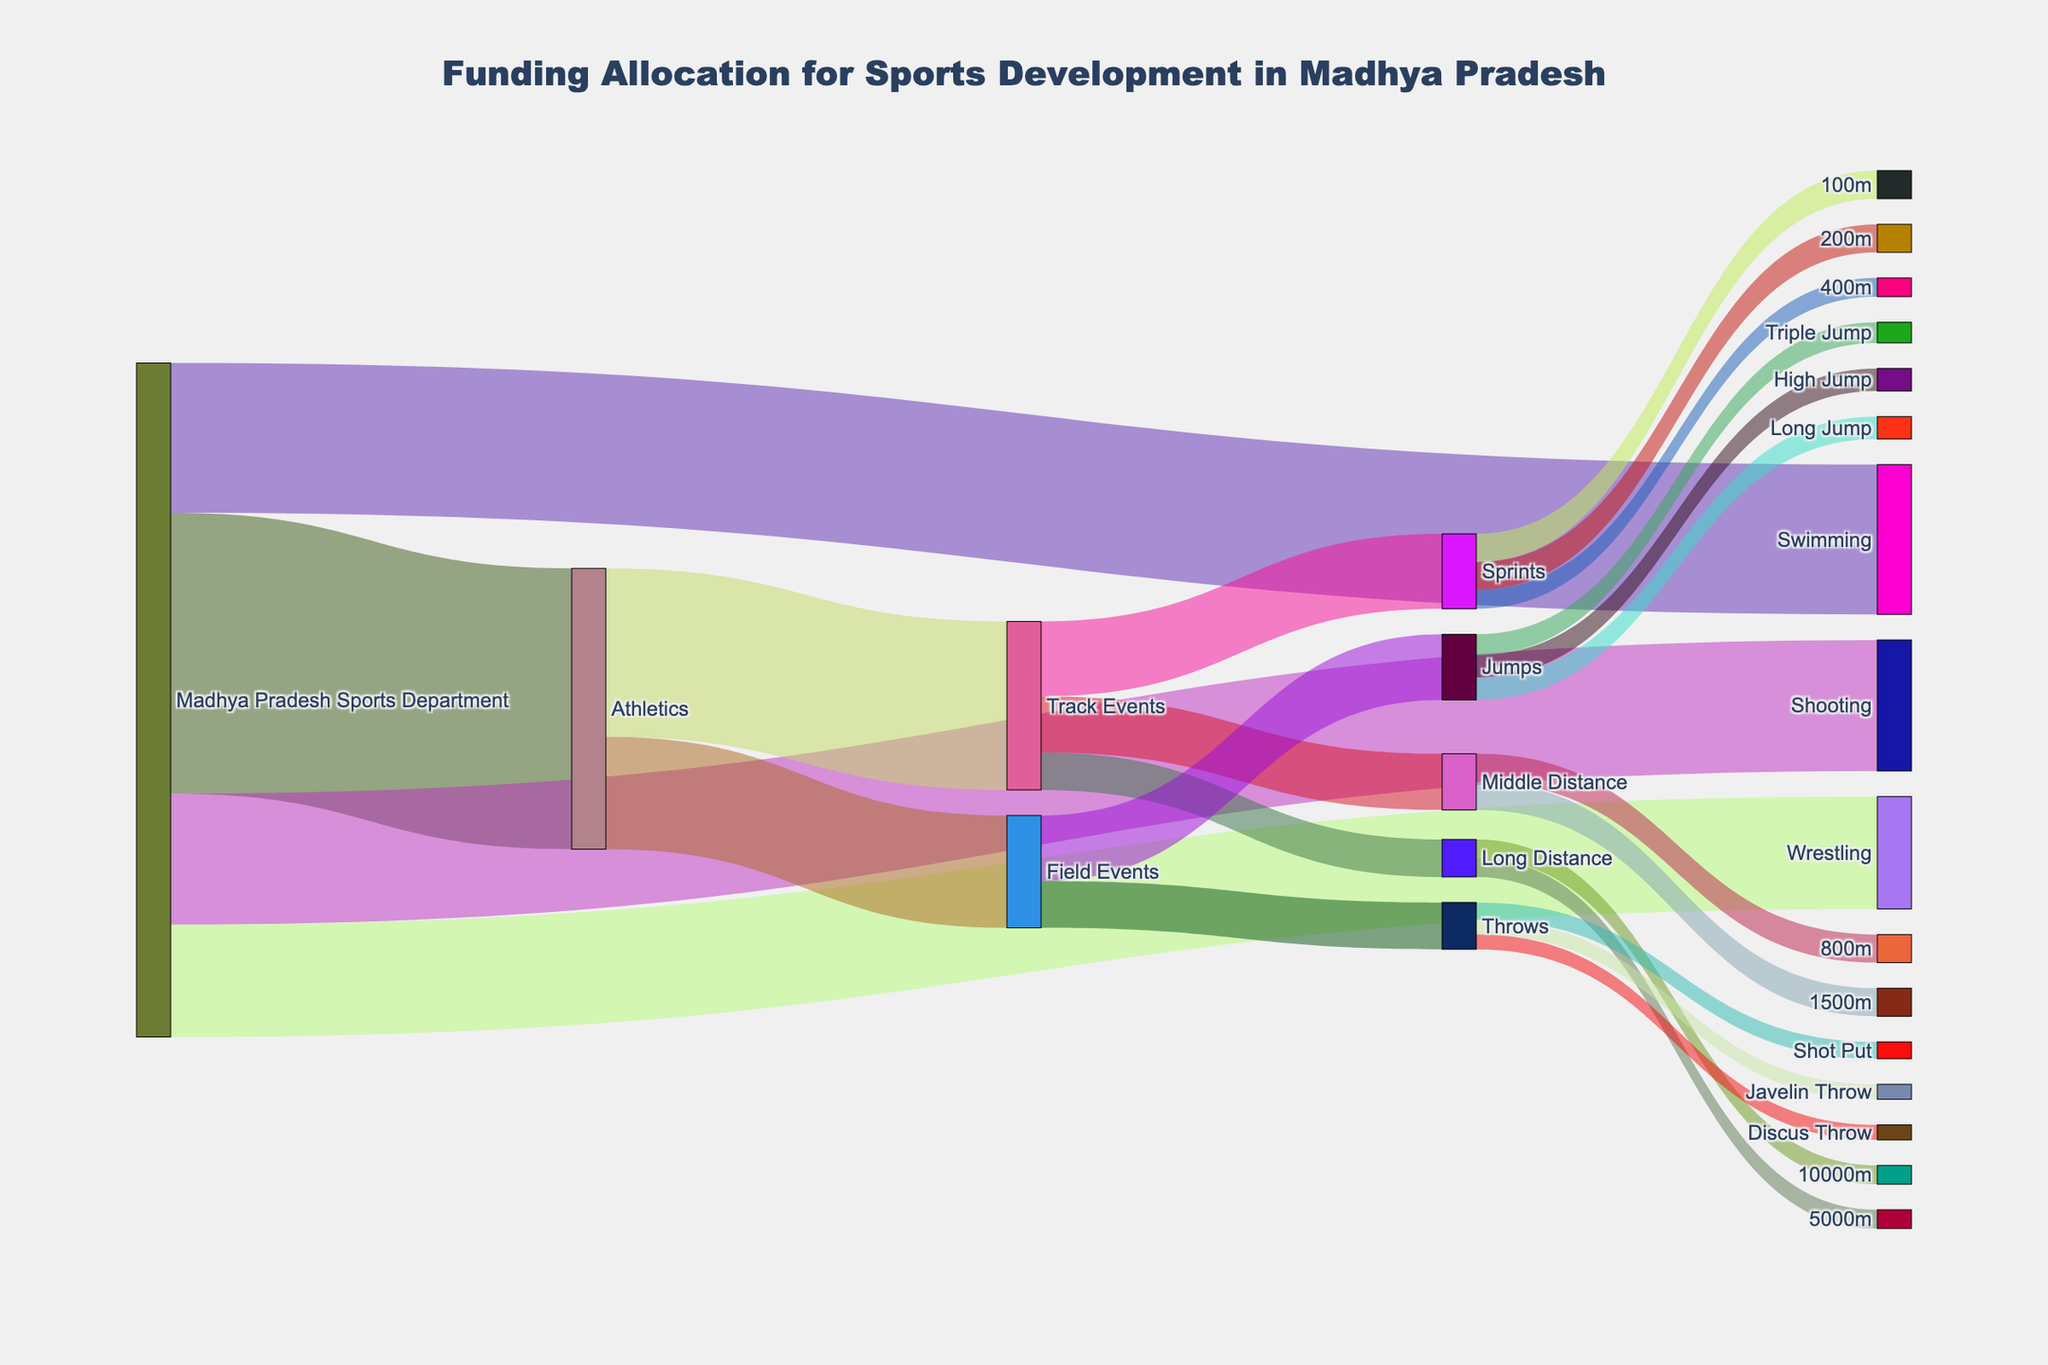How much funding does the Madhya Pradesh Sports Department allocate to Athletics compared to Wrestling? The Sankey Diagram shows funding allocations where Madhya Pradesh Sports Department allocates ₹15,000,000 to Athletics and ₹6,000,000 to Wrestling.
Answer: ₹15,000,000 vs ₹6,000,000 Which Track Event receives the most funding? By examining the Sankey Diagram, we see Track Events splitting into Sprints, Middle Distance, and Long Distance. Sprints gets ₹4,000,000, Middle Distance ₹3,000,000, and Long Distance ₹2,000,000. Sprints receive the most funding.
Answer: Sprints How much total funding is allocated to Field Events? The fields for Field Events are Jumps and Throws, receiving ₹3,500,000 and ₹2,500,000 respectively. Summing these gives ₹3,500,000 + ₹2,500,000 = ₹6,000,000.
Answer: ₹6,000,000 What funding is allocated to the Long Jump event? The Sankey Diagram shows that Jumps within Field Events is further broken down, and Long Jump receives ₹1,200,000.
Answer: ₹1,200,000 Which sports category receives the least overall funding from the Madhya Pradesh Sports Department? Looking at the initial allocations from the Madhya Pradesh Sports Department, funds are directed to Athletics, Swimming, Shooting, and Wrestling. Wrestling receives the least amount at ₹6,000,000.
Answer: Wrestling What's the total funding allocated to Middle Distance track events? The Middle Distance category under Track Events receives funds for 800m and 1500m events. Each event gets ₹1,500,000, summing up to ₹1,500,000 + ₹1,500,000 = ₹3,000,000.
Answer: ₹3,000,000 How does the funding for Sprints compare to that for Throws in Field Events? Expand the Sprints branch and see it has ₹4,000,000 in total, while Throws in Field Events has ₹2,500,000. Sprints receive more funding.
Answer: Sprints have more What is the combined funding allocation for Swimming and Shooting? The figure shows Swimming with ₹8,000,000 and Shooting with ₹7,000,000. Adding these gives ₹8,000,000 + ₹7,000,000 = ₹15,000,000.
Answer: ₹15,000,000 What percentage of the Madhya Pradesh Sports Department's total funding goes to Athletics? Total funding from the Madhya Pradesh Sports Department sums to ₹15,000,000 (Athletics) + ₹8,000,000 (Swimming) + ₹7,000,000 (Shooting) + ₹6,000,000 (Wrestling) = ₹36,000,000. Athletics receives ₹15,000,000. The percentage is (₹15,000,000 / ₹36,000,000) * 100 ≈ 41.67%.
Answer: ≈ 41.67% Between Sprints and Long Distance events, which receives more funding and by how much? Sprints allocations sum to ₹4,000,000, and for Long Distance (5000m and 10000m) it sums to ₹2,000,000. Sprints receive more funding by ₹4,000,000 - ₹2,000,000 = ₹2,000,000.
Answer: Sprints by ₹2,000,000 